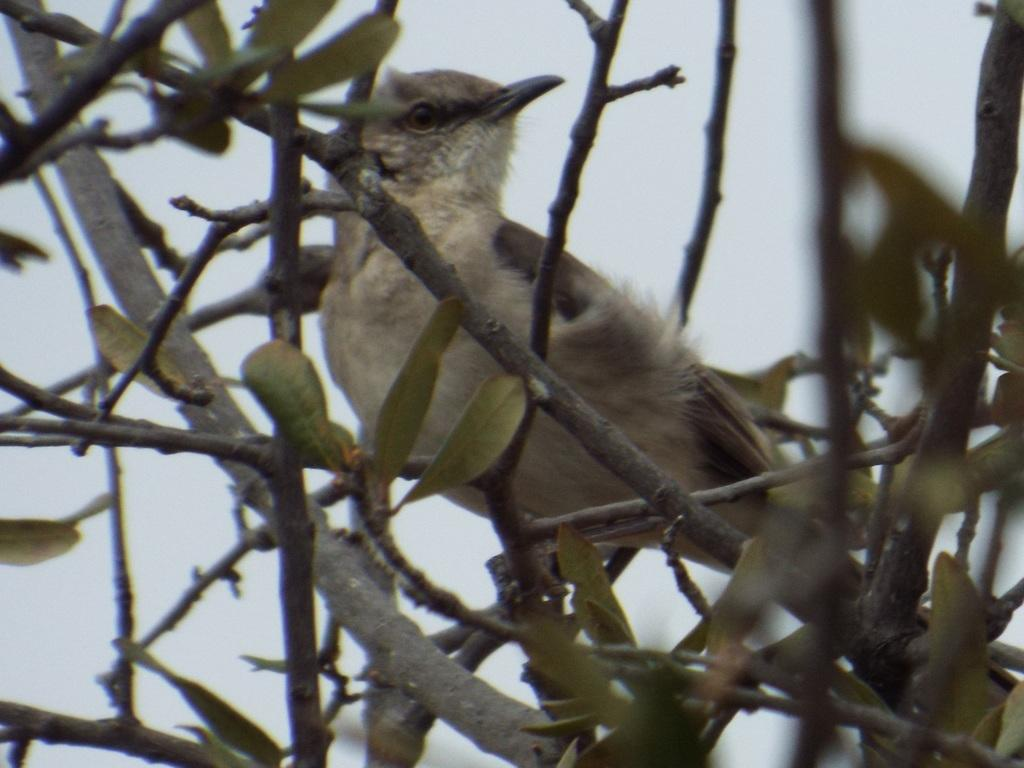What type of animal is in the image? There is a bird in the image. Where is the bird located? The bird is on a tree. Which direction is the bird looking? The bird is looking to the right side. What can be seen at the bottom of the image? There are stems and leaves visible at the bottom of the image. What is visible at the top of the image? The sky is visible at the top of the image. What type of kettle is visible in the image? There is no kettle present in the image. What design can be seen on the bird's feathers in the image? The provided facts do not mention any specific design on the bird's feathers, so we cannot answer this question. 